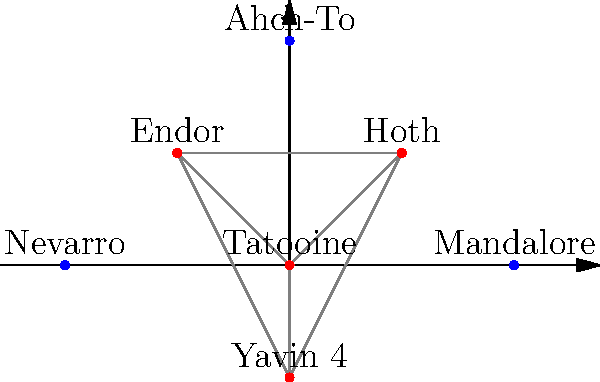Based on the Star Wars galaxy map shown, which planet introduced in the Disney+ series forms an equilateral triangle with two planets from the original trilogy? To determine which planet forms an equilateral triangle with two original trilogy planets, we need to follow these steps:

1. Identify the original trilogy planets: Tatooine, Hoth, Endor, and Yavin 4.
2. Identify the new planets introduced in Disney+ series: Mandalore, Nevarro, and Ahch-To.
3. Check the geometric relationships between the new planets and the original ones:

   a. Mandalore (2,0) forms a right triangle with Tatooine (0,0) and Hoth (1,1).
   b. Nevarro (-2,0) forms a right triangle with Tatooine (0,0) and Endor (-1,1).
   c. Ahch-To (0,2) forms an equilateral triangle with Hoth (1,1) and Endor (-1,1).

4. Verify that Ahch-To, Hoth, and Endor form an equilateral triangle:
   - The distance between Hoth and Endor is $\sqrt{4} = 2$.
   - The distance between Ahch-To and Hoth is $\sqrt{1^2 + 1^2} = \sqrt{2}$.
   - The distance between Ahch-To and Endor is also $\sqrt{1^2 + 1^2} = \sqrt{2}$.

Since all sides of the triangle formed by Ahch-To, Hoth, and Endor are equal, it is an equilateral triangle.
Answer: Ahch-To 